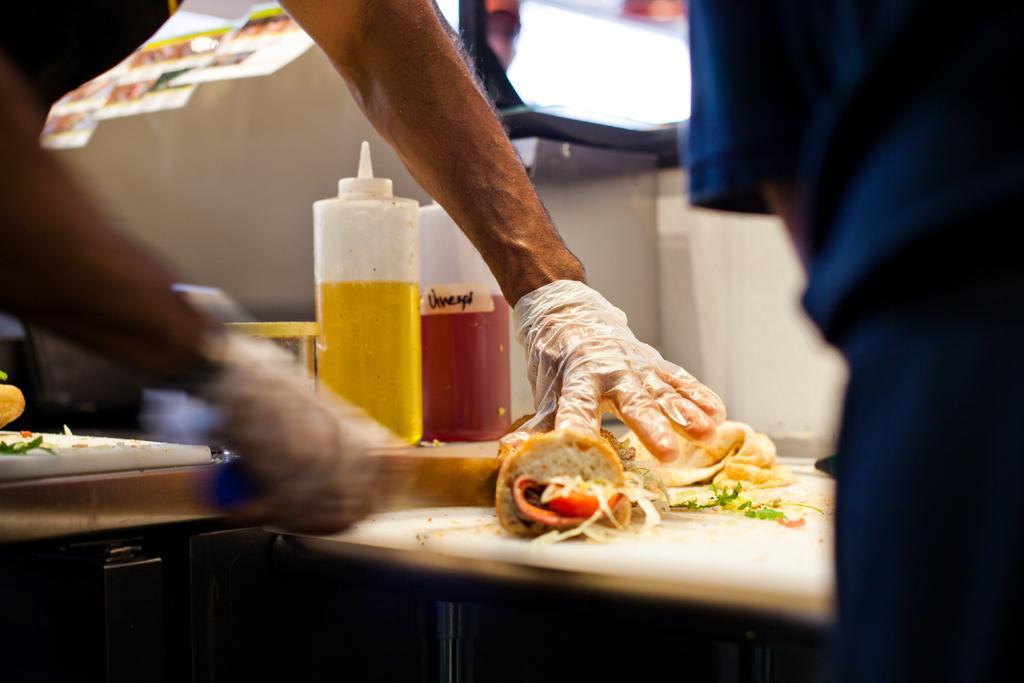How would you summarize this image in a sentence or two? In the picture I can see a person is wearing hand gloves and holding some object in the hand. On the table I can see bottles, food items and some other objects. 